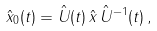Convert formula to latex. <formula><loc_0><loc_0><loc_500><loc_500>\hat { x } _ { 0 } ( t ) = \hat { U } ( t ) \, \hat { x } \, \hat { U } ^ { - 1 } ( t ) \, ,</formula> 